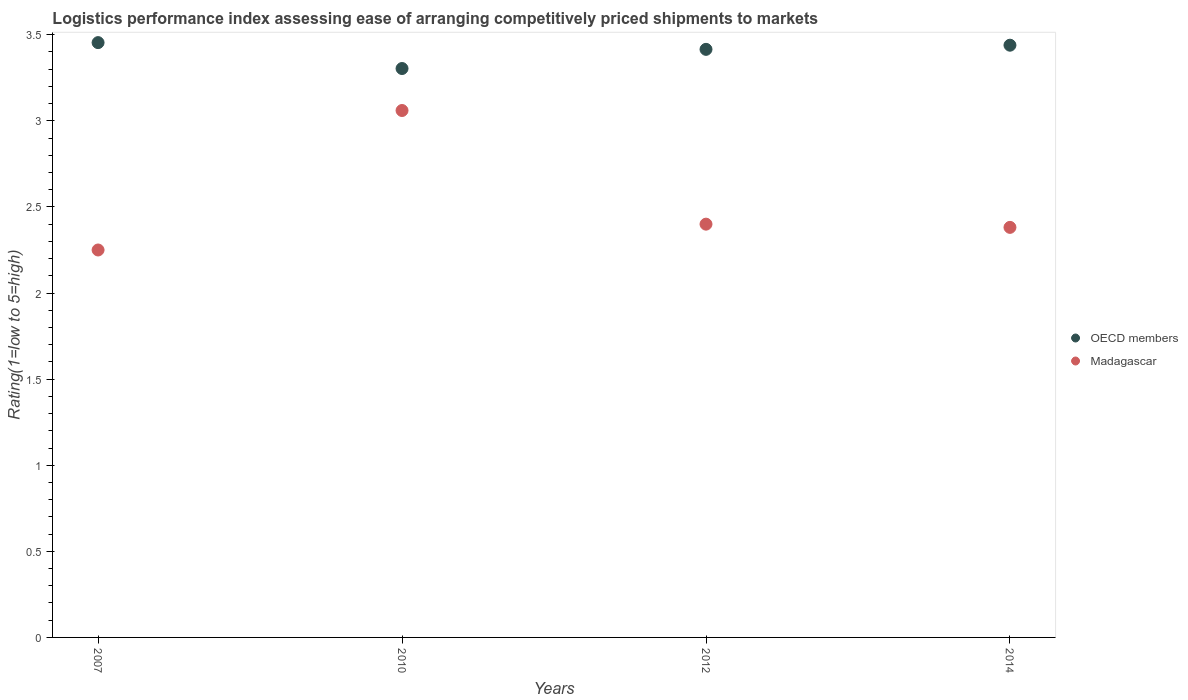How many different coloured dotlines are there?
Provide a succinct answer. 2. Is the number of dotlines equal to the number of legend labels?
Your answer should be very brief. Yes. Across all years, what is the maximum Logistic performance index in OECD members?
Your answer should be very brief. 3.45. Across all years, what is the minimum Logistic performance index in Madagascar?
Give a very brief answer. 2.25. In which year was the Logistic performance index in OECD members maximum?
Offer a very short reply. 2007. What is the total Logistic performance index in Madagascar in the graph?
Offer a very short reply. 10.09. What is the difference between the Logistic performance index in Madagascar in 2010 and that in 2014?
Keep it short and to the point. 0.68. What is the difference between the Logistic performance index in Madagascar in 2012 and the Logistic performance index in OECD members in 2007?
Provide a succinct answer. -1.05. What is the average Logistic performance index in OECD members per year?
Give a very brief answer. 3.4. In the year 2007, what is the difference between the Logistic performance index in Madagascar and Logistic performance index in OECD members?
Keep it short and to the point. -1.2. In how many years, is the Logistic performance index in Madagascar greater than 3.1?
Provide a succinct answer. 0. What is the ratio of the Logistic performance index in Madagascar in 2007 to that in 2010?
Give a very brief answer. 0.74. What is the difference between the highest and the second highest Logistic performance index in OECD members?
Give a very brief answer. 0.02. What is the difference between the highest and the lowest Logistic performance index in OECD members?
Ensure brevity in your answer.  0.15. In how many years, is the Logistic performance index in Madagascar greater than the average Logistic performance index in Madagascar taken over all years?
Provide a short and direct response. 1. Are the values on the major ticks of Y-axis written in scientific E-notation?
Your answer should be very brief. No. How many legend labels are there?
Offer a very short reply. 2. What is the title of the graph?
Keep it short and to the point. Logistics performance index assessing ease of arranging competitively priced shipments to markets. What is the label or title of the X-axis?
Keep it short and to the point. Years. What is the label or title of the Y-axis?
Make the answer very short. Rating(1=low to 5=high). What is the Rating(1=low to 5=high) in OECD members in 2007?
Provide a succinct answer. 3.45. What is the Rating(1=low to 5=high) of Madagascar in 2007?
Give a very brief answer. 2.25. What is the Rating(1=low to 5=high) of OECD members in 2010?
Ensure brevity in your answer.  3.3. What is the Rating(1=low to 5=high) of Madagascar in 2010?
Ensure brevity in your answer.  3.06. What is the Rating(1=low to 5=high) in OECD members in 2012?
Give a very brief answer. 3.42. What is the Rating(1=low to 5=high) in Madagascar in 2012?
Provide a short and direct response. 2.4. What is the Rating(1=low to 5=high) in OECD members in 2014?
Your answer should be compact. 3.44. What is the Rating(1=low to 5=high) in Madagascar in 2014?
Keep it short and to the point. 2.38. Across all years, what is the maximum Rating(1=low to 5=high) of OECD members?
Provide a succinct answer. 3.45. Across all years, what is the maximum Rating(1=low to 5=high) in Madagascar?
Ensure brevity in your answer.  3.06. Across all years, what is the minimum Rating(1=low to 5=high) of OECD members?
Give a very brief answer. 3.3. Across all years, what is the minimum Rating(1=low to 5=high) in Madagascar?
Make the answer very short. 2.25. What is the total Rating(1=low to 5=high) of OECD members in the graph?
Offer a terse response. 13.61. What is the total Rating(1=low to 5=high) in Madagascar in the graph?
Your answer should be compact. 10.09. What is the difference between the Rating(1=low to 5=high) of OECD members in 2007 and that in 2010?
Your answer should be compact. 0.15. What is the difference between the Rating(1=low to 5=high) in Madagascar in 2007 and that in 2010?
Provide a short and direct response. -0.81. What is the difference between the Rating(1=low to 5=high) in OECD members in 2007 and that in 2012?
Your answer should be compact. 0.04. What is the difference between the Rating(1=low to 5=high) of Madagascar in 2007 and that in 2012?
Give a very brief answer. -0.15. What is the difference between the Rating(1=low to 5=high) in OECD members in 2007 and that in 2014?
Provide a short and direct response. 0.01. What is the difference between the Rating(1=low to 5=high) of Madagascar in 2007 and that in 2014?
Your answer should be very brief. -0.13. What is the difference between the Rating(1=low to 5=high) in OECD members in 2010 and that in 2012?
Ensure brevity in your answer.  -0.11. What is the difference between the Rating(1=low to 5=high) of Madagascar in 2010 and that in 2012?
Provide a short and direct response. 0.66. What is the difference between the Rating(1=low to 5=high) in OECD members in 2010 and that in 2014?
Keep it short and to the point. -0.14. What is the difference between the Rating(1=low to 5=high) of Madagascar in 2010 and that in 2014?
Ensure brevity in your answer.  0.68. What is the difference between the Rating(1=low to 5=high) in OECD members in 2012 and that in 2014?
Provide a succinct answer. -0.02. What is the difference between the Rating(1=low to 5=high) of Madagascar in 2012 and that in 2014?
Provide a succinct answer. 0.02. What is the difference between the Rating(1=low to 5=high) of OECD members in 2007 and the Rating(1=low to 5=high) of Madagascar in 2010?
Your response must be concise. 0.39. What is the difference between the Rating(1=low to 5=high) in OECD members in 2007 and the Rating(1=low to 5=high) in Madagascar in 2012?
Offer a very short reply. 1.05. What is the difference between the Rating(1=low to 5=high) in OECD members in 2007 and the Rating(1=low to 5=high) in Madagascar in 2014?
Offer a very short reply. 1.07. What is the difference between the Rating(1=low to 5=high) of OECD members in 2010 and the Rating(1=low to 5=high) of Madagascar in 2012?
Your response must be concise. 0.9. What is the difference between the Rating(1=low to 5=high) of OECD members in 2010 and the Rating(1=low to 5=high) of Madagascar in 2014?
Offer a very short reply. 0.92. What is the difference between the Rating(1=low to 5=high) of OECD members in 2012 and the Rating(1=low to 5=high) of Madagascar in 2014?
Provide a short and direct response. 1.03. What is the average Rating(1=low to 5=high) of OECD members per year?
Offer a terse response. 3.4. What is the average Rating(1=low to 5=high) in Madagascar per year?
Make the answer very short. 2.52. In the year 2007, what is the difference between the Rating(1=low to 5=high) in OECD members and Rating(1=low to 5=high) in Madagascar?
Offer a terse response. 1.2. In the year 2010, what is the difference between the Rating(1=low to 5=high) of OECD members and Rating(1=low to 5=high) of Madagascar?
Your answer should be compact. 0.24. In the year 2012, what is the difference between the Rating(1=low to 5=high) in OECD members and Rating(1=low to 5=high) in Madagascar?
Ensure brevity in your answer.  1.02. In the year 2014, what is the difference between the Rating(1=low to 5=high) in OECD members and Rating(1=low to 5=high) in Madagascar?
Your response must be concise. 1.06. What is the ratio of the Rating(1=low to 5=high) in OECD members in 2007 to that in 2010?
Provide a succinct answer. 1.05. What is the ratio of the Rating(1=low to 5=high) of Madagascar in 2007 to that in 2010?
Ensure brevity in your answer.  0.74. What is the ratio of the Rating(1=low to 5=high) of OECD members in 2007 to that in 2012?
Your answer should be compact. 1.01. What is the ratio of the Rating(1=low to 5=high) in Madagascar in 2007 to that in 2014?
Your answer should be compact. 0.94. What is the ratio of the Rating(1=low to 5=high) of OECD members in 2010 to that in 2012?
Provide a succinct answer. 0.97. What is the ratio of the Rating(1=low to 5=high) of Madagascar in 2010 to that in 2012?
Give a very brief answer. 1.27. What is the ratio of the Rating(1=low to 5=high) of OECD members in 2010 to that in 2014?
Provide a short and direct response. 0.96. What is the ratio of the Rating(1=low to 5=high) in Madagascar in 2010 to that in 2014?
Your answer should be compact. 1.28. What is the ratio of the Rating(1=low to 5=high) in OECD members in 2012 to that in 2014?
Your answer should be compact. 0.99. What is the difference between the highest and the second highest Rating(1=low to 5=high) in OECD members?
Your answer should be very brief. 0.01. What is the difference between the highest and the second highest Rating(1=low to 5=high) in Madagascar?
Provide a succinct answer. 0.66. What is the difference between the highest and the lowest Rating(1=low to 5=high) in OECD members?
Give a very brief answer. 0.15. What is the difference between the highest and the lowest Rating(1=low to 5=high) of Madagascar?
Provide a succinct answer. 0.81. 